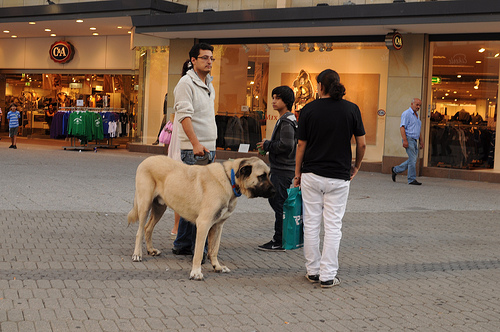Is the kid to the left or to the right of the man that is on the right of the picture? The kid is to the left of the man located on the right side of the picture, appearing quite engaged in their interaction. 